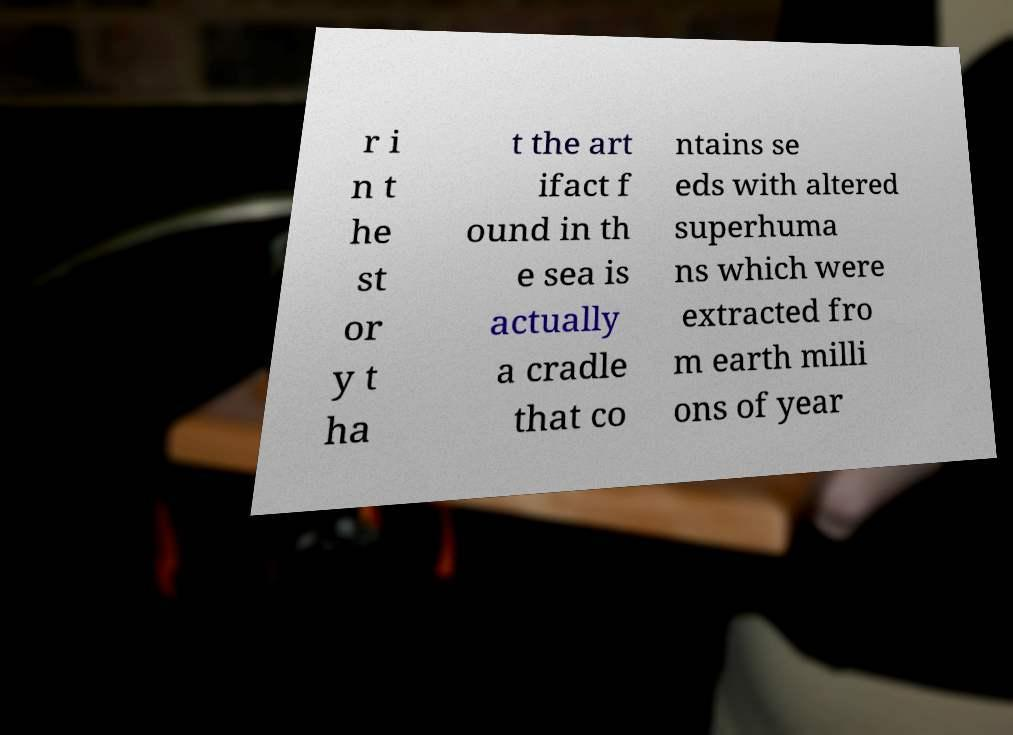I need the written content from this picture converted into text. Can you do that? r i n t he st or y t ha t the art ifact f ound in th e sea is actually a cradle that co ntains se eds with altered superhuma ns which were extracted fro m earth milli ons of year 